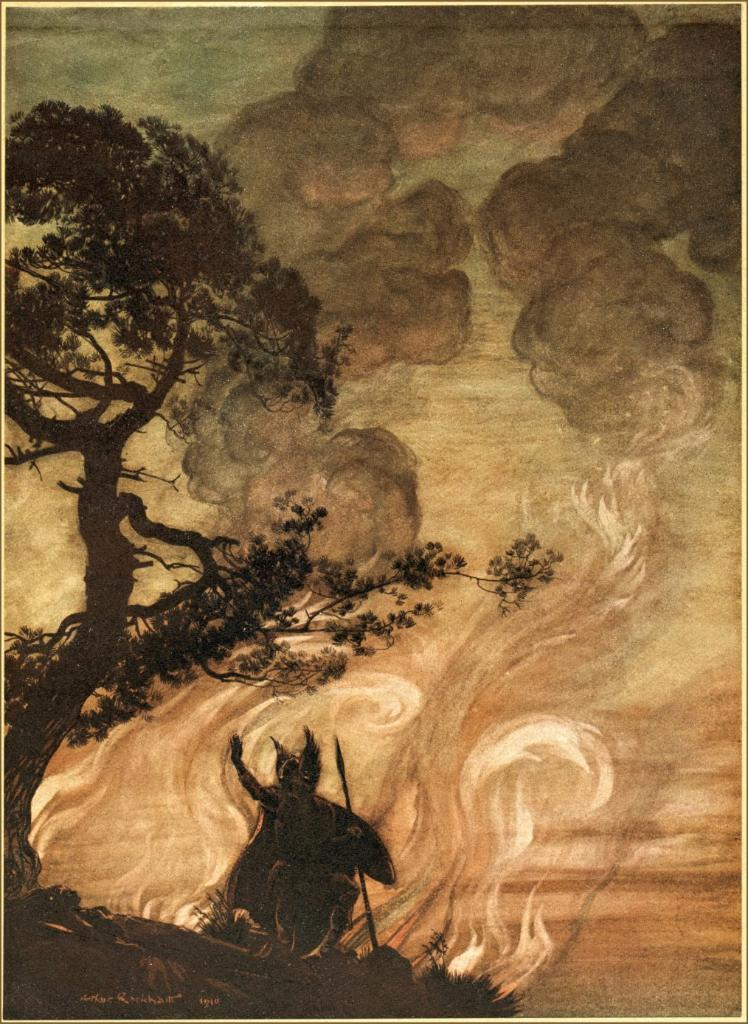What is the main subject of the image? There is an art piece in the image. What is depicted in the art piece? The art piece contains a tree. Can you describe any other objects or features in the art piece? There is a black colored object on the ground in the art piece. What can be seen in the background of the image? There is fire, smoke, and the sky visible in the background of the image. What type of jelly is being used to create the smoke effect in the image? There is no jelly present in the image; the smoke is a result of the fire in the background. 